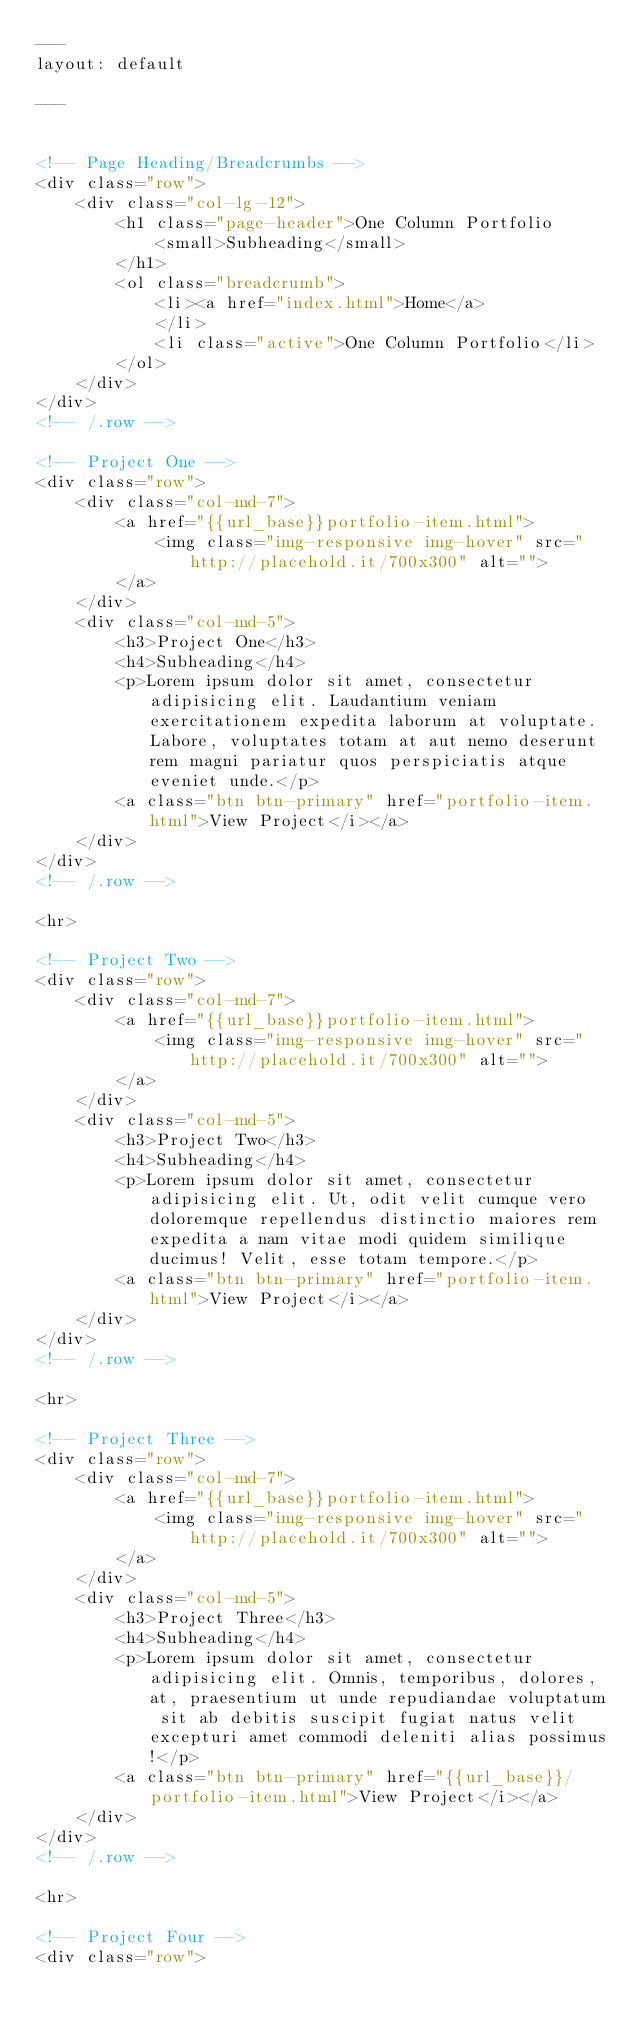Convert code to text. <code><loc_0><loc_0><loc_500><loc_500><_HTML_>---
layout: default

---


<!-- Page Heading/Breadcrumbs -->
<div class="row">
    <div class="col-lg-12">
        <h1 class="page-header">One Column Portfolio
            <small>Subheading</small>
        </h1>
        <ol class="breadcrumb">
            <li><a href="index.html">Home</a>
            </li>
            <li class="active">One Column Portfolio</li>
        </ol>
    </div>
</div>
<!-- /.row -->

<!-- Project One -->
<div class="row">
    <div class="col-md-7">
        <a href="{{url_base}}portfolio-item.html">
            <img class="img-responsive img-hover" src="http://placehold.it/700x300" alt="">
        </a>
    </div>
    <div class="col-md-5">
        <h3>Project One</h3>
        <h4>Subheading</h4>
        <p>Lorem ipsum dolor sit amet, consectetur adipisicing elit. Laudantium veniam exercitationem expedita laborum at voluptate. Labore, voluptates totam at aut nemo deserunt rem magni pariatur quos perspiciatis atque eveniet unde.</p>
        <a class="btn btn-primary" href="portfolio-item.html">View Project</i></a>
    </div>
</div>
<!-- /.row -->

<hr>

<!-- Project Two -->
<div class="row">
    <div class="col-md-7">
        <a href="{{url_base}}portfolio-item.html">
            <img class="img-responsive img-hover" src="http://placehold.it/700x300" alt="">
        </a>
    </div>
    <div class="col-md-5">
        <h3>Project Two</h3>
        <h4>Subheading</h4>
        <p>Lorem ipsum dolor sit amet, consectetur adipisicing elit. Ut, odit velit cumque vero doloremque repellendus distinctio maiores rem expedita a nam vitae modi quidem similique ducimus! Velit, esse totam tempore.</p>
        <a class="btn btn-primary" href="portfolio-item.html">View Project</i></a>
    </div>
</div>
<!-- /.row -->

<hr>

<!-- Project Three -->
<div class="row">
    <div class="col-md-7">
        <a href="{{url_base}}portfolio-item.html">
            <img class="img-responsive img-hover" src="http://placehold.it/700x300" alt="">
        </a>
    </div>
    <div class="col-md-5">
        <h3>Project Three</h3>
        <h4>Subheading</h4>
        <p>Lorem ipsum dolor sit amet, consectetur adipisicing elit. Omnis, temporibus, dolores, at, praesentium ut unde repudiandae voluptatum sit ab debitis suscipit fugiat natus velit excepturi amet commodi deleniti alias possimus!</p>
        <a class="btn btn-primary" href="{{url_base}}/portfolio-item.html">View Project</i></a>
    </div>
</div>
<!-- /.row -->

<hr>

<!-- Project Four -->
<div class="row">
</code> 